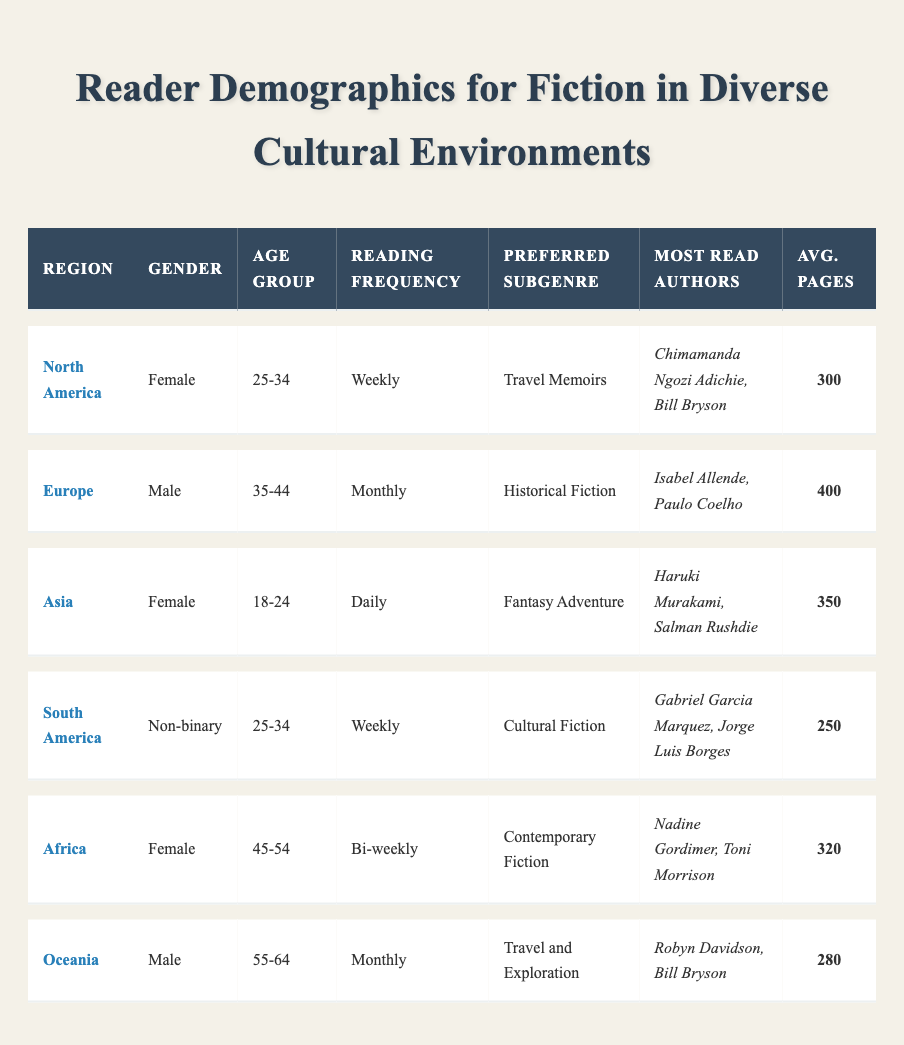What is the preferred subgenre of female readers in North America? In the table, the demographic for North America is listed as female readers aged 25-34, whose preferred subgenre is "Travel Memoirs."
Answer: Travel Memoirs How many average pages do the readers from South America read? The demographic data for South America shows that the average pages per book are listed as 250.
Answer: 250 Do readers in Asia prefer travel memoirs? The demographic for Asia indicates that the preferred subgenre is "Fantasy Adventure," not travel memoirs, so the statement is false.
Answer: No What is the reading frequency of male readers in Europe? The table lists the reading frequency for male readers in Europe as "Monthly."
Answer: Monthly Among all the demographics, which age group has the highest average pages per book? Comparing the average pages for each region, the age group 35-44 from Europe has the highest average at 400 pages per book.
Answer: 35-44 How many of the demographics prefer Cultural Fiction? Only one demographic, from South America, has the preferred subgenre as Cultural Fiction, so the answer is one.
Answer: One Is there a non-binary reader demographic in Oceania? Checking the table indicates that the non-binary demographic is found in South America, not Oceania, therefore, the statement is false.
Answer: No Which region has female readers aged 45-54? The table identifies Africa as having female readers in the age group 45-54.
Answer: Africa What is the average number of pages read per book by male readers? After reviewing the table, the average pages read per book by male readers in Europe is 400, and in Oceania is 280. The overall average is (400 + 280) / 2 = 340.
Answer: 340 How does the reading frequency compare between female readers in North America and male readers in Oceania? Female readers in North America read weekly, while male readers in Oceania read monthly. Thus, female readers read more frequently than male readers in Oceania.
Answer: Female readers read more frequently 